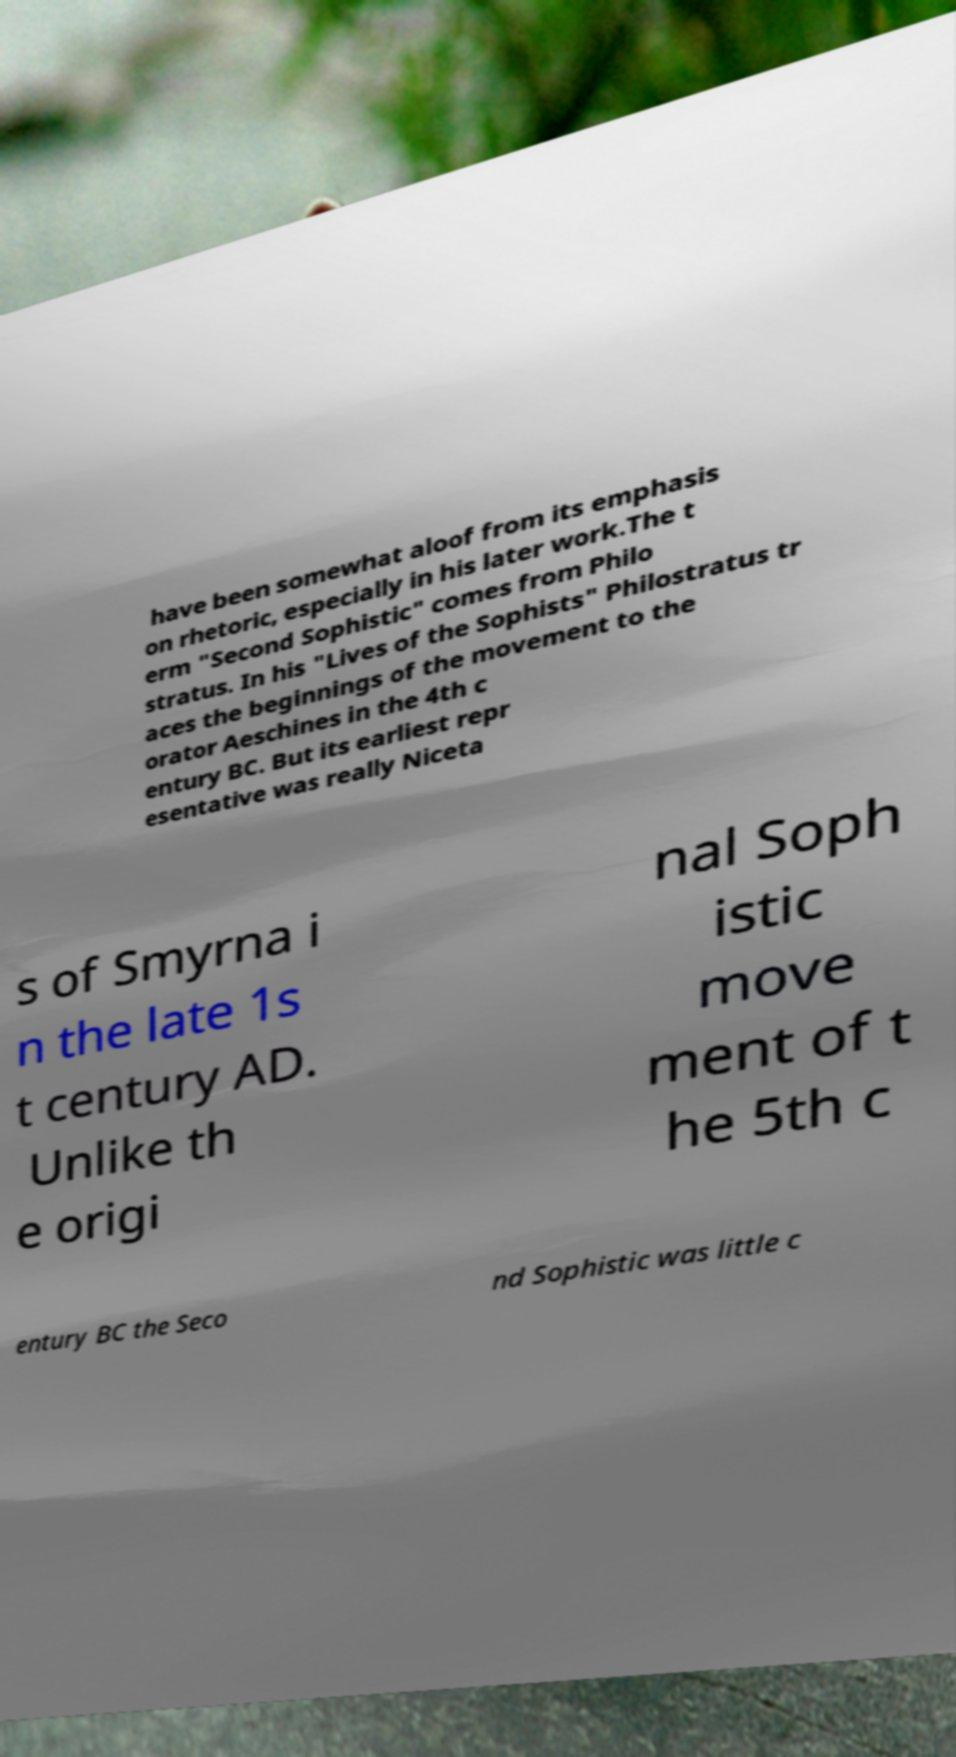Please read and relay the text visible in this image. What does it say? have been somewhat aloof from its emphasis on rhetoric, especially in his later work.The t erm "Second Sophistic" comes from Philo stratus. In his "Lives of the Sophists" Philostratus tr aces the beginnings of the movement to the orator Aeschines in the 4th c entury BC. But its earliest repr esentative was really Niceta s of Smyrna i n the late 1s t century AD. Unlike th e origi nal Soph istic move ment of t he 5th c entury BC the Seco nd Sophistic was little c 